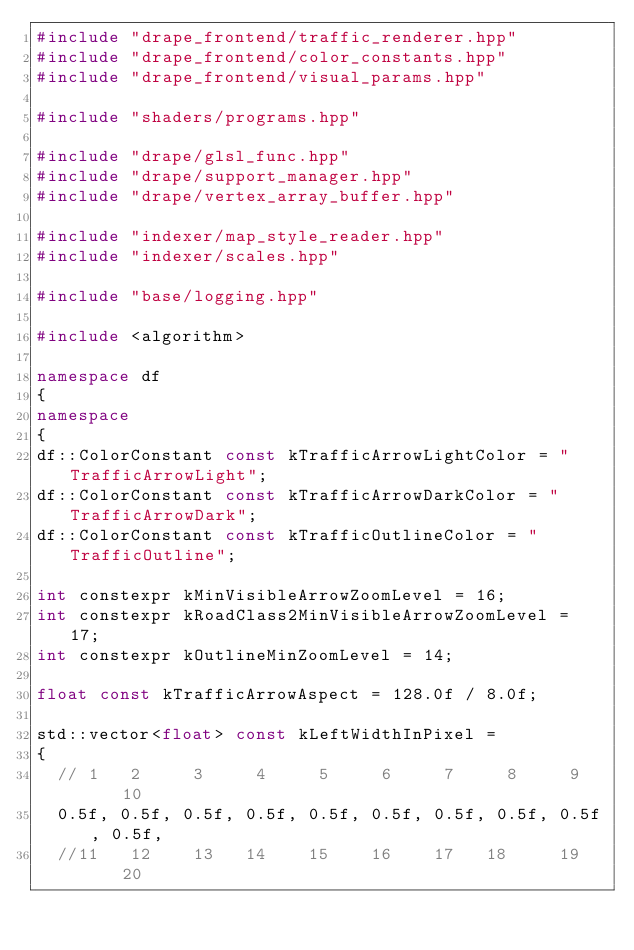Convert code to text. <code><loc_0><loc_0><loc_500><loc_500><_C++_>#include "drape_frontend/traffic_renderer.hpp"
#include "drape_frontend/color_constants.hpp"
#include "drape_frontend/visual_params.hpp"

#include "shaders/programs.hpp"

#include "drape/glsl_func.hpp"
#include "drape/support_manager.hpp"
#include "drape/vertex_array_buffer.hpp"

#include "indexer/map_style_reader.hpp"
#include "indexer/scales.hpp"

#include "base/logging.hpp"

#include <algorithm>

namespace df
{
namespace
{
df::ColorConstant const kTrafficArrowLightColor = "TrafficArrowLight";
df::ColorConstant const kTrafficArrowDarkColor = "TrafficArrowDark";
df::ColorConstant const kTrafficOutlineColor = "TrafficOutline";

int constexpr kMinVisibleArrowZoomLevel = 16;
int constexpr kRoadClass2MinVisibleArrowZoomLevel = 17;
int constexpr kOutlineMinZoomLevel = 14;

float const kTrafficArrowAspect = 128.0f / 8.0f;

std::vector<float> const kLeftWidthInPixel =
{
  // 1   2     3     4     5     6     7     8     9    10
  0.5f, 0.5f, 0.5f, 0.5f, 0.5f, 0.5f, 0.5f, 0.5f, 0.5f, 0.5f,
  //11   12    13   14    15    16    17   18     19    20</code> 